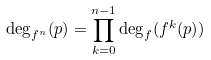<formula> <loc_0><loc_0><loc_500><loc_500>\deg _ { f ^ { n } } ( p ) = \prod _ { k = 0 } ^ { n - 1 } \deg _ { f } ( f ^ { k } ( p ) )</formula> 